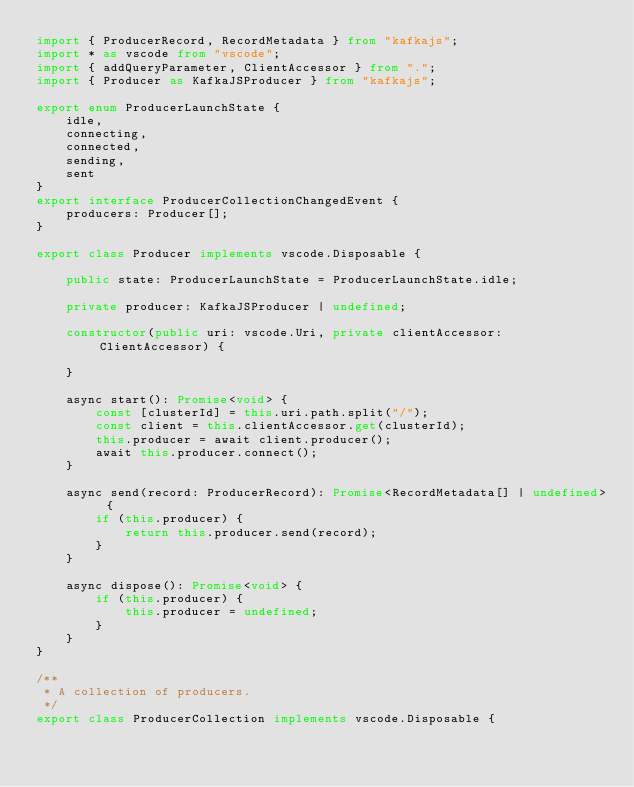<code> <loc_0><loc_0><loc_500><loc_500><_TypeScript_>import { ProducerRecord, RecordMetadata } from "kafkajs";
import * as vscode from "vscode";
import { addQueryParameter, ClientAccessor } from ".";
import { Producer as KafkaJSProducer } from "kafkajs";

export enum ProducerLaunchState {
    idle,
    connecting,
    connected,
    sending,
    sent
}
export interface ProducerCollectionChangedEvent {
    producers: Producer[];
}

export class Producer implements vscode.Disposable {

    public state: ProducerLaunchState = ProducerLaunchState.idle;

    private producer: KafkaJSProducer | undefined;

    constructor(public uri: vscode.Uri, private clientAccessor: ClientAccessor) {

    }

    async start(): Promise<void> {
        const [clusterId] = this.uri.path.split("/");
        const client = this.clientAccessor.get(clusterId);
        this.producer = await client.producer();
        await this.producer.connect();
    }

    async send(record: ProducerRecord): Promise<RecordMetadata[] | undefined> {
        if (this.producer) {
            return this.producer.send(record);
        }
    }

    async dispose(): Promise<void> {
        if (this.producer) {
            this.producer = undefined;
        }
    }
}

/**
 * A collection of producers.
 */
export class ProducerCollection implements vscode.Disposable {
</code> 